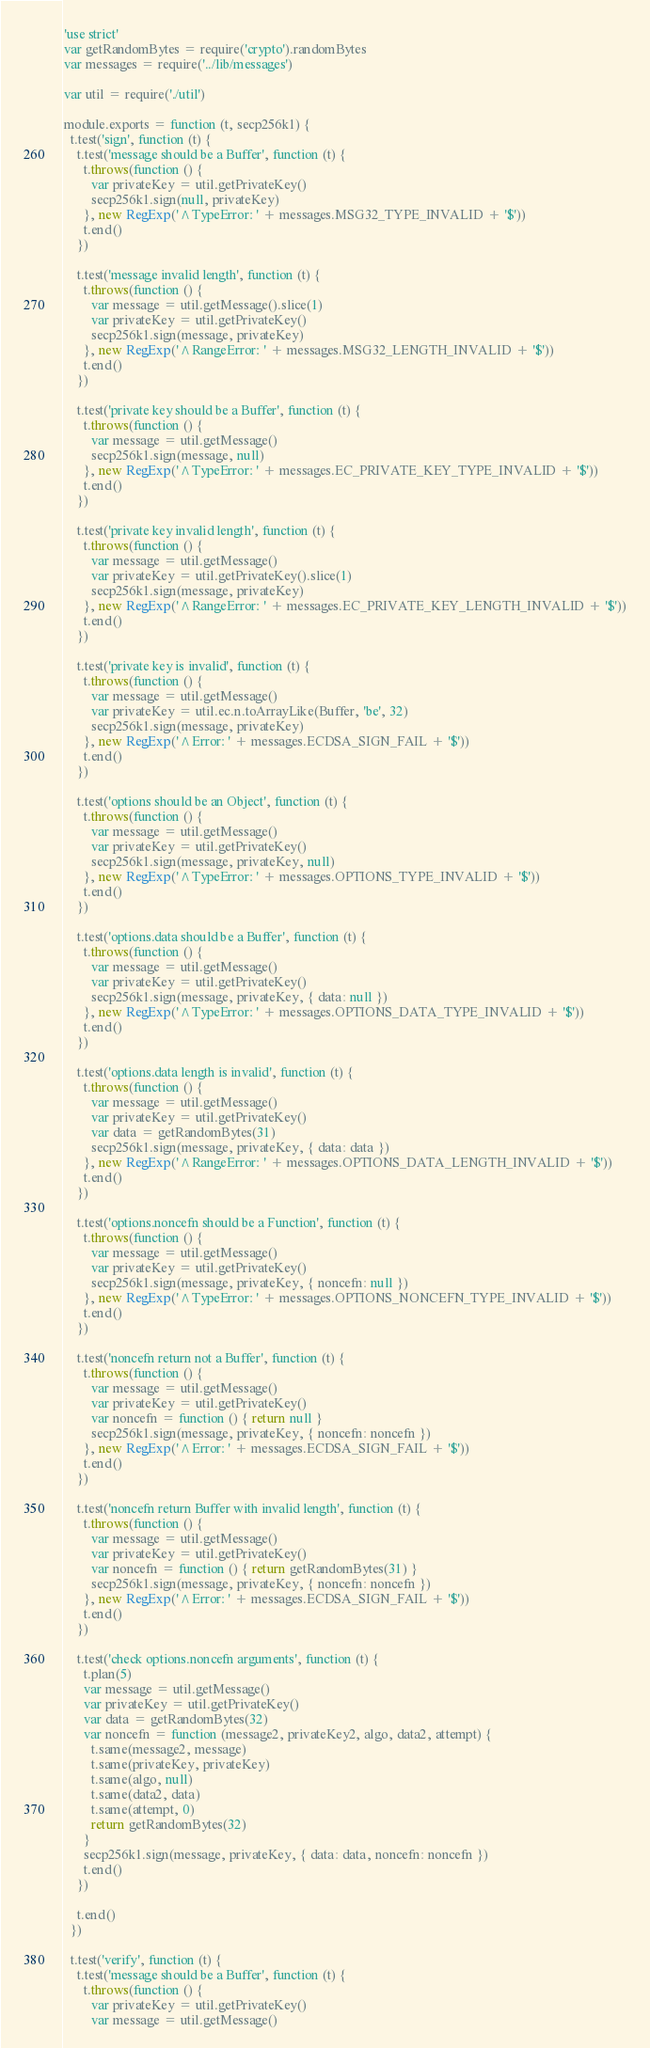Convert code to text. <code><loc_0><loc_0><loc_500><loc_500><_JavaScript_>'use strict'
var getRandomBytes = require('crypto').randomBytes
var messages = require('../lib/messages')

var util = require('./util')

module.exports = function (t, secp256k1) {
  t.test('sign', function (t) {
    t.test('message should be a Buffer', function (t) {
      t.throws(function () {
        var privateKey = util.getPrivateKey()
        secp256k1.sign(null, privateKey)
      }, new RegExp('^TypeError: ' + messages.MSG32_TYPE_INVALID + '$'))
      t.end()
    })

    t.test('message invalid length', function (t) {
      t.throws(function () {
        var message = util.getMessage().slice(1)
        var privateKey = util.getPrivateKey()
        secp256k1.sign(message, privateKey)
      }, new RegExp('^RangeError: ' + messages.MSG32_LENGTH_INVALID + '$'))
      t.end()
    })

    t.test('private key should be a Buffer', function (t) {
      t.throws(function () {
        var message = util.getMessage()
        secp256k1.sign(message, null)
      }, new RegExp('^TypeError: ' + messages.EC_PRIVATE_KEY_TYPE_INVALID + '$'))
      t.end()
    })

    t.test('private key invalid length', function (t) {
      t.throws(function () {
        var message = util.getMessage()
        var privateKey = util.getPrivateKey().slice(1)
        secp256k1.sign(message, privateKey)
      }, new RegExp('^RangeError: ' + messages.EC_PRIVATE_KEY_LENGTH_INVALID + '$'))
      t.end()
    })

    t.test('private key is invalid', function (t) {
      t.throws(function () {
        var message = util.getMessage()
        var privateKey = util.ec.n.toArrayLike(Buffer, 'be', 32)
        secp256k1.sign(message, privateKey)
      }, new RegExp('^Error: ' + messages.ECDSA_SIGN_FAIL + '$'))
      t.end()
    })

    t.test('options should be an Object', function (t) {
      t.throws(function () {
        var message = util.getMessage()
        var privateKey = util.getPrivateKey()
        secp256k1.sign(message, privateKey, null)
      }, new RegExp('^TypeError: ' + messages.OPTIONS_TYPE_INVALID + '$'))
      t.end()
    })

    t.test('options.data should be a Buffer', function (t) {
      t.throws(function () {
        var message = util.getMessage()
        var privateKey = util.getPrivateKey()
        secp256k1.sign(message, privateKey, { data: null })
      }, new RegExp('^TypeError: ' + messages.OPTIONS_DATA_TYPE_INVALID + '$'))
      t.end()
    })

    t.test('options.data length is invalid', function (t) {
      t.throws(function () {
        var message = util.getMessage()
        var privateKey = util.getPrivateKey()
        var data = getRandomBytes(31)
        secp256k1.sign(message, privateKey, { data: data })
      }, new RegExp('^RangeError: ' + messages.OPTIONS_DATA_LENGTH_INVALID + '$'))
      t.end()
    })

    t.test('options.noncefn should be a Function', function (t) {
      t.throws(function () {
        var message = util.getMessage()
        var privateKey = util.getPrivateKey()
        secp256k1.sign(message, privateKey, { noncefn: null })
      }, new RegExp('^TypeError: ' + messages.OPTIONS_NONCEFN_TYPE_INVALID + '$'))
      t.end()
    })

    t.test('noncefn return not a Buffer', function (t) {
      t.throws(function () {
        var message = util.getMessage()
        var privateKey = util.getPrivateKey()
        var noncefn = function () { return null }
        secp256k1.sign(message, privateKey, { noncefn: noncefn })
      }, new RegExp('^Error: ' + messages.ECDSA_SIGN_FAIL + '$'))
      t.end()
    })

    t.test('noncefn return Buffer with invalid length', function (t) {
      t.throws(function () {
        var message = util.getMessage()
        var privateKey = util.getPrivateKey()
        var noncefn = function () { return getRandomBytes(31) }
        secp256k1.sign(message, privateKey, { noncefn: noncefn })
      }, new RegExp('^Error: ' + messages.ECDSA_SIGN_FAIL + '$'))
      t.end()
    })

    t.test('check options.noncefn arguments', function (t) {
      t.plan(5)
      var message = util.getMessage()
      var privateKey = util.getPrivateKey()
      var data = getRandomBytes(32)
      var noncefn = function (message2, privateKey2, algo, data2, attempt) {
        t.same(message2, message)
        t.same(privateKey, privateKey)
        t.same(algo, null)
        t.same(data2, data)
        t.same(attempt, 0)
        return getRandomBytes(32)
      }
      secp256k1.sign(message, privateKey, { data: data, noncefn: noncefn })
      t.end()
    })

    t.end()
  })

  t.test('verify', function (t) {
    t.test('message should be a Buffer', function (t) {
      t.throws(function () {
        var privateKey = util.getPrivateKey()
        var message = util.getMessage()</code> 